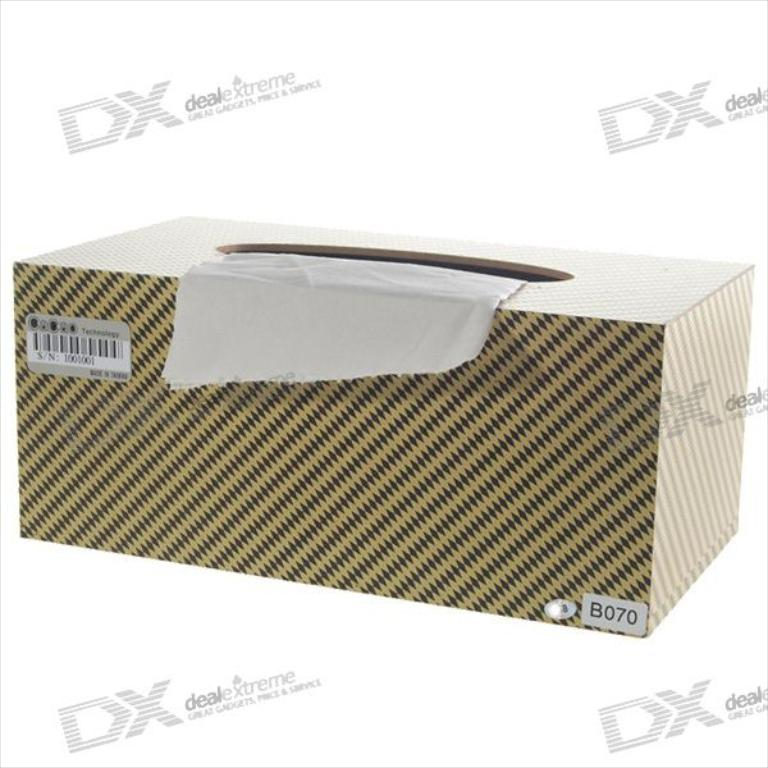Provide a one-sentence caption for the provided image. A box of tissues encased in a distinctive, houndstooth-patterned packaging branded with 'DX: Deal Extreme', highlighting a product available in an online marketplace. 